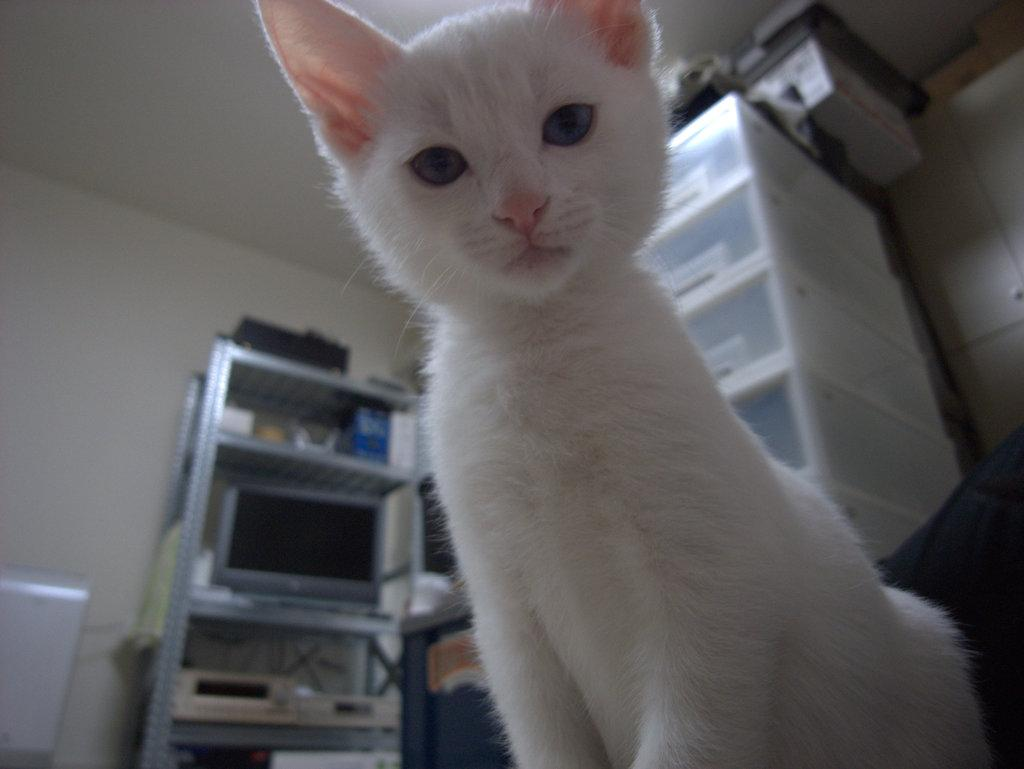What is the main subject of the image? There is a white color cat in the center of the image. What can be seen in the background of the image? There are boxes and a rack in the background of the image. How many dimes are scattered around the cat in the image? There are no dimes present in the image; it features a white color cat and background elements. 